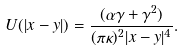Convert formula to latex. <formula><loc_0><loc_0><loc_500><loc_500>U ( | { x } - { y } | ) = \frac { ( \alpha \gamma + \gamma ^ { 2 } ) } { ( \pi \kappa ) ^ { 2 } | { x } - { y } | ^ { 4 } } .</formula> 